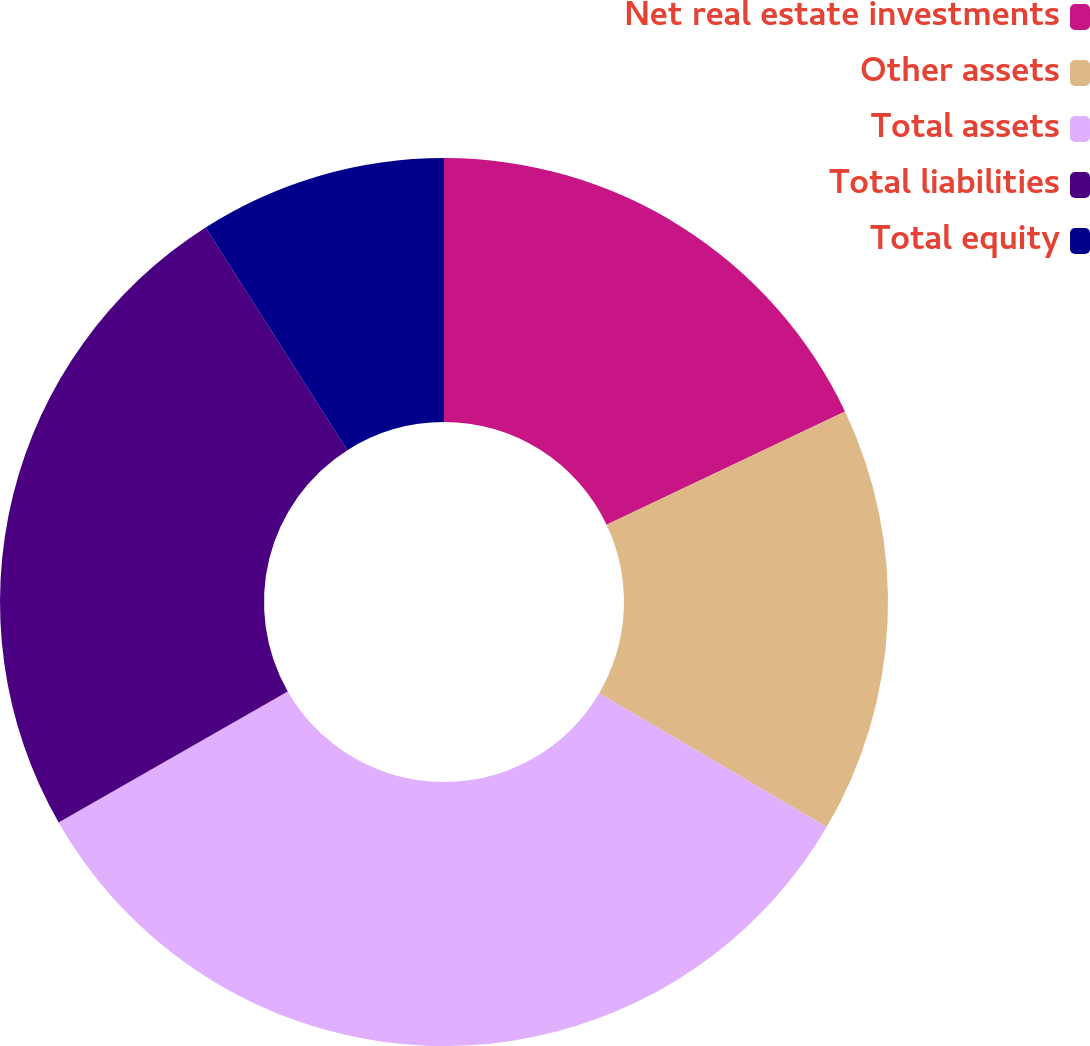Convert chart to OTSL. <chart><loc_0><loc_0><loc_500><loc_500><pie_chart><fcel>Net real estate investments<fcel>Other assets<fcel>Total assets<fcel>Total liabilities<fcel>Total equity<nl><fcel>17.94%<fcel>15.52%<fcel>33.27%<fcel>24.25%<fcel>9.02%<nl></chart> 